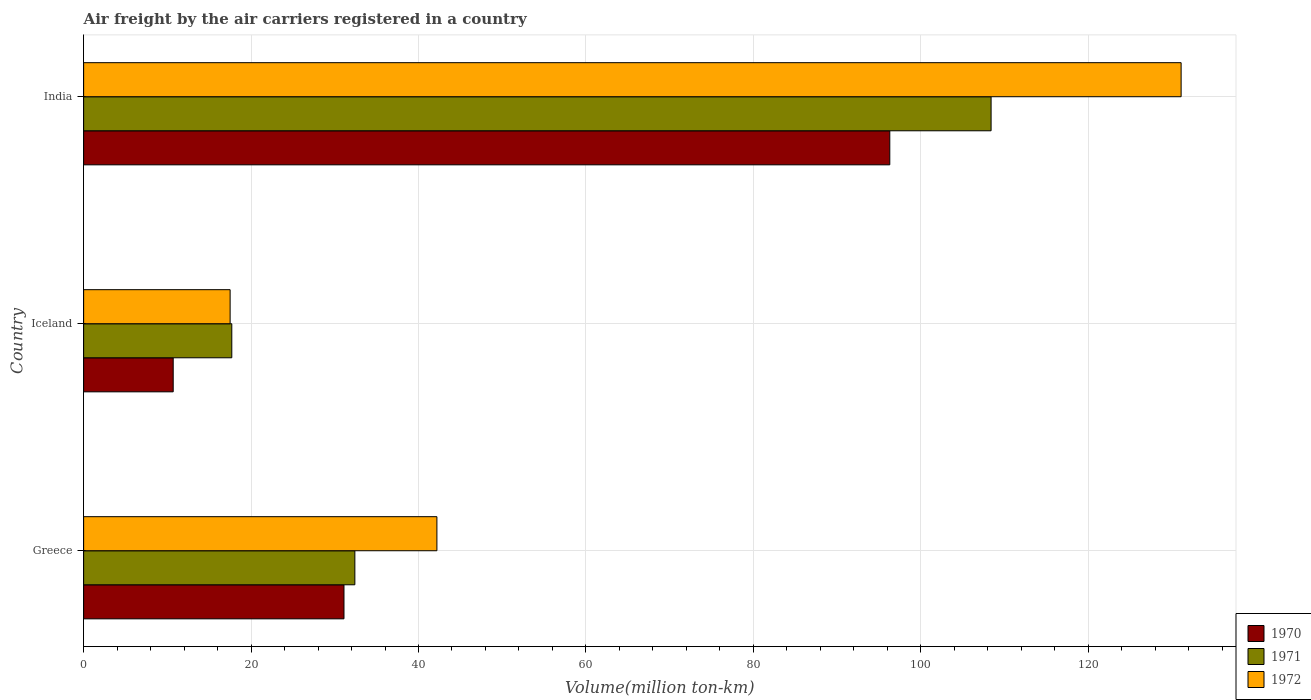Are the number of bars on each tick of the Y-axis equal?
Your answer should be compact. Yes. What is the label of the 3rd group of bars from the top?
Your answer should be compact. Greece. What is the volume of the air carriers in 1971 in Greece?
Your answer should be very brief. 32.4. Across all countries, what is the maximum volume of the air carriers in 1971?
Ensure brevity in your answer.  108.4. Across all countries, what is the minimum volume of the air carriers in 1971?
Provide a short and direct response. 17.7. In which country was the volume of the air carriers in 1971 maximum?
Make the answer very short. India. In which country was the volume of the air carriers in 1971 minimum?
Your answer should be very brief. Iceland. What is the total volume of the air carriers in 1971 in the graph?
Give a very brief answer. 158.5. What is the difference between the volume of the air carriers in 1970 in Iceland and that in India?
Make the answer very short. -85.6. What is the difference between the volume of the air carriers in 1971 in Greece and the volume of the air carriers in 1972 in India?
Your response must be concise. -98.7. What is the average volume of the air carriers in 1971 per country?
Offer a very short reply. 52.83. What is the difference between the volume of the air carriers in 1971 and volume of the air carriers in 1970 in Iceland?
Offer a very short reply. 7. What is the ratio of the volume of the air carriers in 1971 in Iceland to that in India?
Your answer should be compact. 0.16. Is the volume of the air carriers in 1972 in Iceland less than that in India?
Your response must be concise. Yes. Is the difference between the volume of the air carriers in 1971 in Greece and Iceland greater than the difference between the volume of the air carriers in 1970 in Greece and Iceland?
Make the answer very short. No. What is the difference between the highest and the second highest volume of the air carriers in 1970?
Offer a very short reply. 65.2. What is the difference between the highest and the lowest volume of the air carriers in 1971?
Keep it short and to the point. 90.7. In how many countries, is the volume of the air carriers in 1970 greater than the average volume of the air carriers in 1970 taken over all countries?
Offer a terse response. 1. What does the 1st bar from the bottom in Iceland represents?
Ensure brevity in your answer.  1970. Is it the case that in every country, the sum of the volume of the air carriers in 1972 and volume of the air carriers in 1971 is greater than the volume of the air carriers in 1970?
Provide a short and direct response. Yes. Are all the bars in the graph horizontal?
Your answer should be compact. Yes. What is the title of the graph?
Make the answer very short. Air freight by the air carriers registered in a country. What is the label or title of the X-axis?
Provide a succinct answer. Volume(million ton-km). What is the label or title of the Y-axis?
Your answer should be compact. Country. What is the Volume(million ton-km) of 1970 in Greece?
Provide a succinct answer. 31.1. What is the Volume(million ton-km) of 1971 in Greece?
Make the answer very short. 32.4. What is the Volume(million ton-km) of 1972 in Greece?
Ensure brevity in your answer.  42.2. What is the Volume(million ton-km) in 1970 in Iceland?
Provide a succinct answer. 10.7. What is the Volume(million ton-km) of 1971 in Iceland?
Offer a very short reply. 17.7. What is the Volume(million ton-km) of 1972 in Iceland?
Your answer should be very brief. 17.5. What is the Volume(million ton-km) of 1970 in India?
Give a very brief answer. 96.3. What is the Volume(million ton-km) in 1971 in India?
Provide a short and direct response. 108.4. What is the Volume(million ton-km) of 1972 in India?
Provide a succinct answer. 131.1. Across all countries, what is the maximum Volume(million ton-km) of 1970?
Offer a terse response. 96.3. Across all countries, what is the maximum Volume(million ton-km) of 1971?
Your answer should be very brief. 108.4. Across all countries, what is the maximum Volume(million ton-km) in 1972?
Ensure brevity in your answer.  131.1. Across all countries, what is the minimum Volume(million ton-km) of 1970?
Ensure brevity in your answer.  10.7. Across all countries, what is the minimum Volume(million ton-km) in 1971?
Your answer should be very brief. 17.7. What is the total Volume(million ton-km) in 1970 in the graph?
Make the answer very short. 138.1. What is the total Volume(million ton-km) in 1971 in the graph?
Offer a terse response. 158.5. What is the total Volume(million ton-km) in 1972 in the graph?
Provide a succinct answer. 190.8. What is the difference between the Volume(million ton-km) of 1970 in Greece and that in Iceland?
Your answer should be compact. 20.4. What is the difference between the Volume(million ton-km) of 1971 in Greece and that in Iceland?
Ensure brevity in your answer.  14.7. What is the difference between the Volume(million ton-km) of 1972 in Greece and that in Iceland?
Give a very brief answer. 24.7. What is the difference between the Volume(million ton-km) of 1970 in Greece and that in India?
Give a very brief answer. -65.2. What is the difference between the Volume(million ton-km) in 1971 in Greece and that in India?
Offer a terse response. -76. What is the difference between the Volume(million ton-km) in 1972 in Greece and that in India?
Your answer should be compact. -88.9. What is the difference between the Volume(million ton-km) of 1970 in Iceland and that in India?
Provide a short and direct response. -85.6. What is the difference between the Volume(million ton-km) in 1971 in Iceland and that in India?
Keep it short and to the point. -90.7. What is the difference between the Volume(million ton-km) in 1972 in Iceland and that in India?
Make the answer very short. -113.6. What is the difference between the Volume(million ton-km) in 1970 in Greece and the Volume(million ton-km) in 1971 in Iceland?
Provide a short and direct response. 13.4. What is the difference between the Volume(million ton-km) in 1971 in Greece and the Volume(million ton-km) in 1972 in Iceland?
Offer a terse response. 14.9. What is the difference between the Volume(million ton-km) of 1970 in Greece and the Volume(million ton-km) of 1971 in India?
Your response must be concise. -77.3. What is the difference between the Volume(million ton-km) in 1970 in Greece and the Volume(million ton-km) in 1972 in India?
Keep it short and to the point. -100. What is the difference between the Volume(million ton-km) of 1971 in Greece and the Volume(million ton-km) of 1972 in India?
Offer a very short reply. -98.7. What is the difference between the Volume(million ton-km) of 1970 in Iceland and the Volume(million ton-km) of 1971 in India?
Give a very brief answer. -97.7. What is the difference between the Volume(million ton-km) of 1970 in Iceland and the Volume(million ton-km) of 1972 in India?
Ensure brevity in your answer.  -120.4. What is the difference between the Volume(million ton-km) in 1971 in Iceland and the Volume(million ton-km) in 1972 in India?
Give a very brief answer. -113.4. What is the average Volume(million ton-km) in 1970 per country?
Provide a short and direct response. 46.03. What is the average Volume(million ton-km) of 1971 per country?
Ensure brevity in your answer.  52.83. What is the average Volume(million ton-km) in 1972 per country?
Your answer should be compact. 63.6. What is the difference between the Volume(million ton-km) of 1971 and Volume(million ton-km) of 1972 in Greece?
Your response must be concise. -9.8. What is the difference between the Volume(million ton-km) of 1970 and Volume(million ton-km) of 1971 in Iceland?
Offer a very short reply. -7. What is the difference between the Volume(million ton-km) in 1970 and Volume(million ton-km) in 1972 in Iceland?
Make the answer very short. -6.8. What is the difference between the Volume(million ton-km) of 1971 and Volume(million ton-km) of 1972 in Iceland?
Your response must be concise. 0.2. What is the difference between the Volume(million ton-km) in 1970 and Volume(million ton-km) in 1972 in India?
Your answer should be very brief. -34.8. What is the difference between the Volume(million ton-km) in 1971 and Volume(million ton-km) in 1972 in India?
Offer a terse response. -22.7. What is the ratio of the Volume(million ton-km) of 1970 in Greece to that in Iceland?
Give a very brief answer. 2.91. What is the ratio of the Volume(million ton-km) in 1971 in Greece to that in Iceland?
Give a very brief answer. 1.83. What is the ratio of the Volume(million ton-km) of 1972 in Greece to that in Iceland?
Provide a short and direct response. 2.41. What is the ratio of the Volume(million ton-km) in 1970 in Greece to that in India?
Your answer should be very brief. 0.32. What is the ratio of the Volume(million ton-km) in 1971 in Greece to that in India?
Provide a succinct answer. 0.3. What is the ratio of the Volume(million ton-km) of 1972 in Greece to that in India?
Offer a terse response. 0.32. What is the ratio of the Volume(million ton-km) in 1971 in Iceland to that in India?
Your answer should be very brief. 0.16. What is the ratio of the Volume(million ton-km) of 1972 in Iceland to that in India?
Offer a very short reply. 0.13. What is the difference between the highest and the second highest Volume(million ton-km) of 1970?
Provide a short and direct response. 65.2. What is the difference between the highest and the second highest Volume(million ton-km) in 1971?
Offer a very short reply. 76. What is the difference between the highest and the second highest Volume(million ton-km) in 1972?
Provide a short and direct response. 88.9. What is the difference between the highest and the lowest Volume(million ton-km) in 1970?
Provide a short and direct response. 85.6. What is the difference between the highest and the lowest Volume(million ton-km) of 1971?
Offer a terse response. 90.7. What is the difference between the highest and the lowest Volume(million ton-km) in 1972?
Your response must be concise. 113.6. 